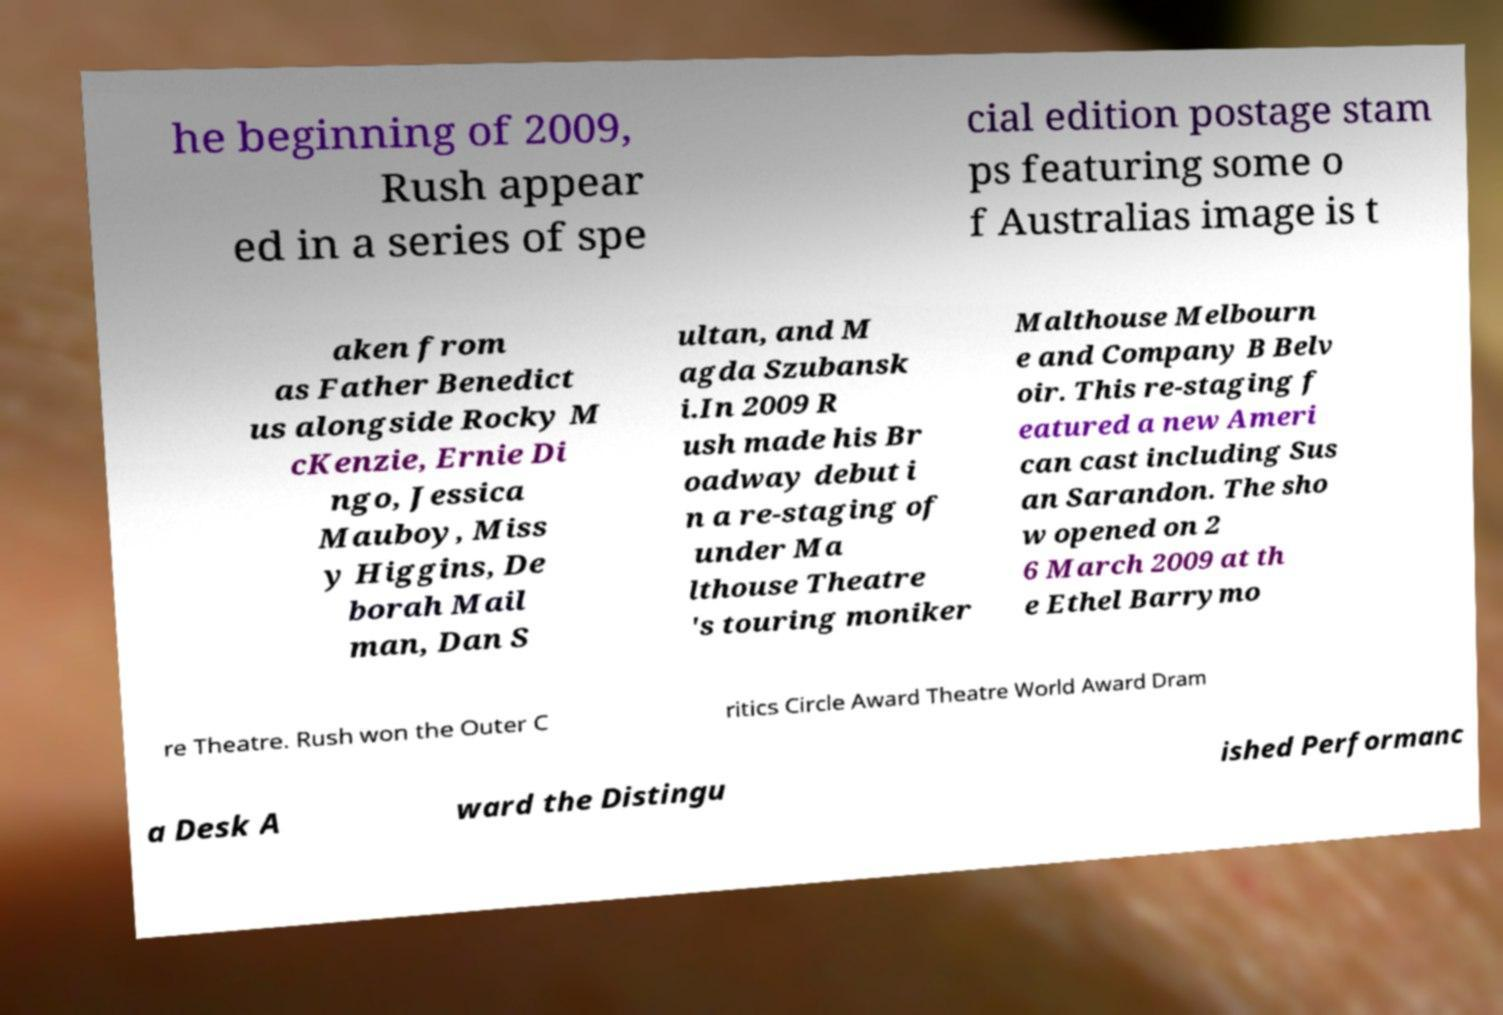For documentation purposes, I need the text within this image transcribed. Could you provide that? he beginning of 2009, Rush appear ed in a series of spe cial edition postage stam ps featuring some o f Australias image is t aken from as Father Benedict us alongside Rocky M cKenzie, Ernie Di ngo, Jessica Mauboy, Miss y Higgins, De borah Mail man, Dan S ultan, and M agda Szubansk i.In 2009 R ush made his Br oadway debut i n a re-staging of under Ma lthouse Theatre 's touring moniker Malthouse Melbourn e and Company B Belv oir. This re-staging f eatured a new Ameri can cast including Sus an Sarandon. The sho w opened on 2 6 March 2009 at th e Ethel Barrymo re Theatre. Rush won the Outer C ritics Circle Award Theatre World Award Dram a Desk A ward the Distingu ished Performanc 